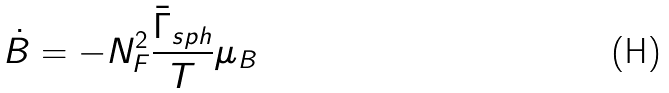<formula> <loc_0><loc_0><loc_500><loc_500>\dot { B } = - N _ { F } ^ { 2 } \frac { \bar { \Gamma } _ { s p h } } { T } \mu _ { B }</formula> 